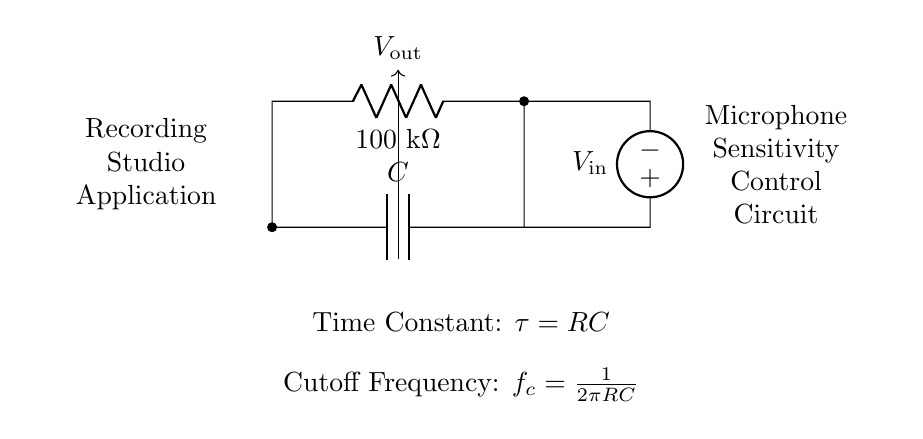What is the resistance value in the circuit? The resistance component labeled "R" is specified as 100 kΩ, which is indicated directly on the circuit diagram.
Answer: 100 kΩ What is the capacitance value in this circuit? The circuit diagram does not specify a numerical value for the capacitance "C," leaving it as generic. Therefore, the capacitance value is not defined in this particular illustration.
Answer: Not defined What is the time constant formula represented in this circuit? The formula for the time constant is shown in the circuit diagram as τ = RC, where R is the resistance and C is the capacitance. This relationship is fundamental to RC circuits, indicating the time required for the voltage to rise to approximately 63.2% of its maximum value.
Answer: τ = RC What is the equation for the cutoff frequency in this circuit? The cutoff frequency formula is displayed in the circuit as f_c = 1/(2πRC), indicating the frequency at which the output voltage is reduced to 70.7% of the input voltage. This is specifically for RC circuits that filter signals.
Answer: f_c = 1/(2πRC) What role does the capacitor play in controlling microphone sensitivity? The capacitor's role in an RC circuit is to filter and smooth out voltage fluctuations, which in this application helps regulate the microphone's sensitivity, ensuring consistent audio levels for recordings.
Answer: Filtering What does the voltage source represent in the circuit? The voltage source, labeled V_in, provides the input voltage to the circuit, necessary for the operation of the resistor-capacitor combination, and ultimately impacts the output voltage V_out.
Answer: Input voltage What is the purpose of this circuit in a recording studio application? This circuit is designed to control the sensitivity of microphones, ensuring a stable and appropriate signal level during audio recordings, which is crucial for achieving high-quality sound.
Answer: Microphone sensitivity control 